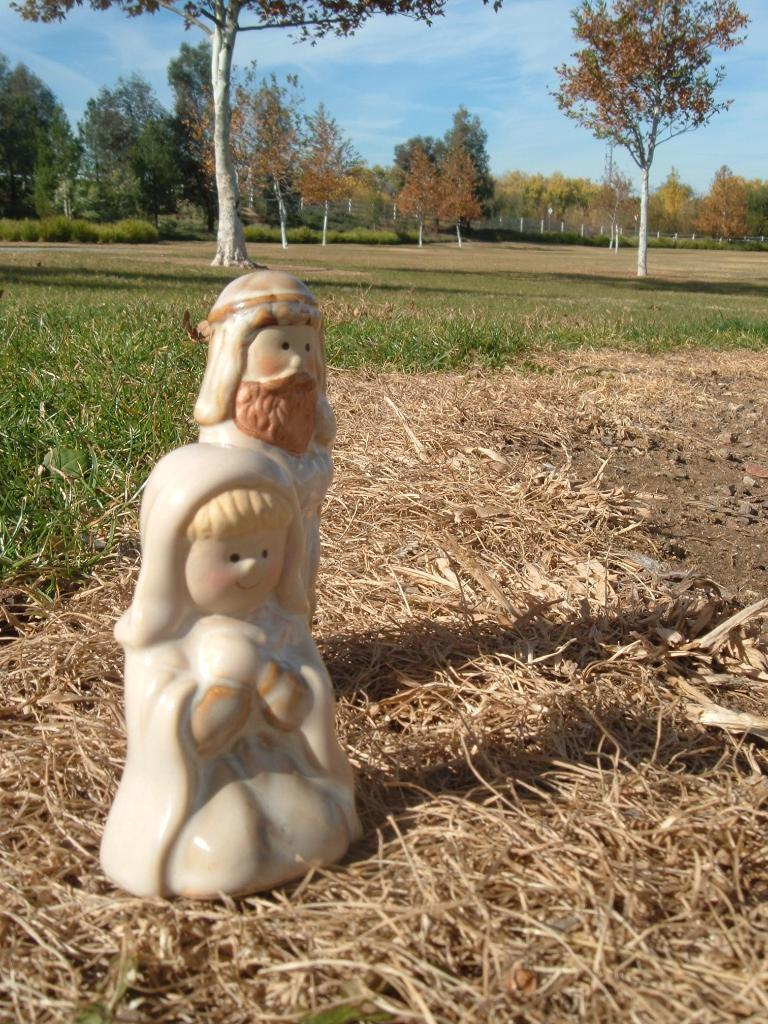What is the main subject in the image? There is a statue in the image. Where is the statue located? The statue is on dry grass. What can be seen in the background of the image? There is a ground with trees in the background of the image. What is visible at the top of the image? The sky is visible at the top of the image. What type of vegetation is present at the bottom of the image? Dry grass is present at the bottom of the image. What type of trade is happening between the statue and the trees in the image? There is no trade happening between the statue and the trees in the image, as they are inanimate objects. Can you see any feathers on the statue in the image? There are no feathers present on the statue in the image. 